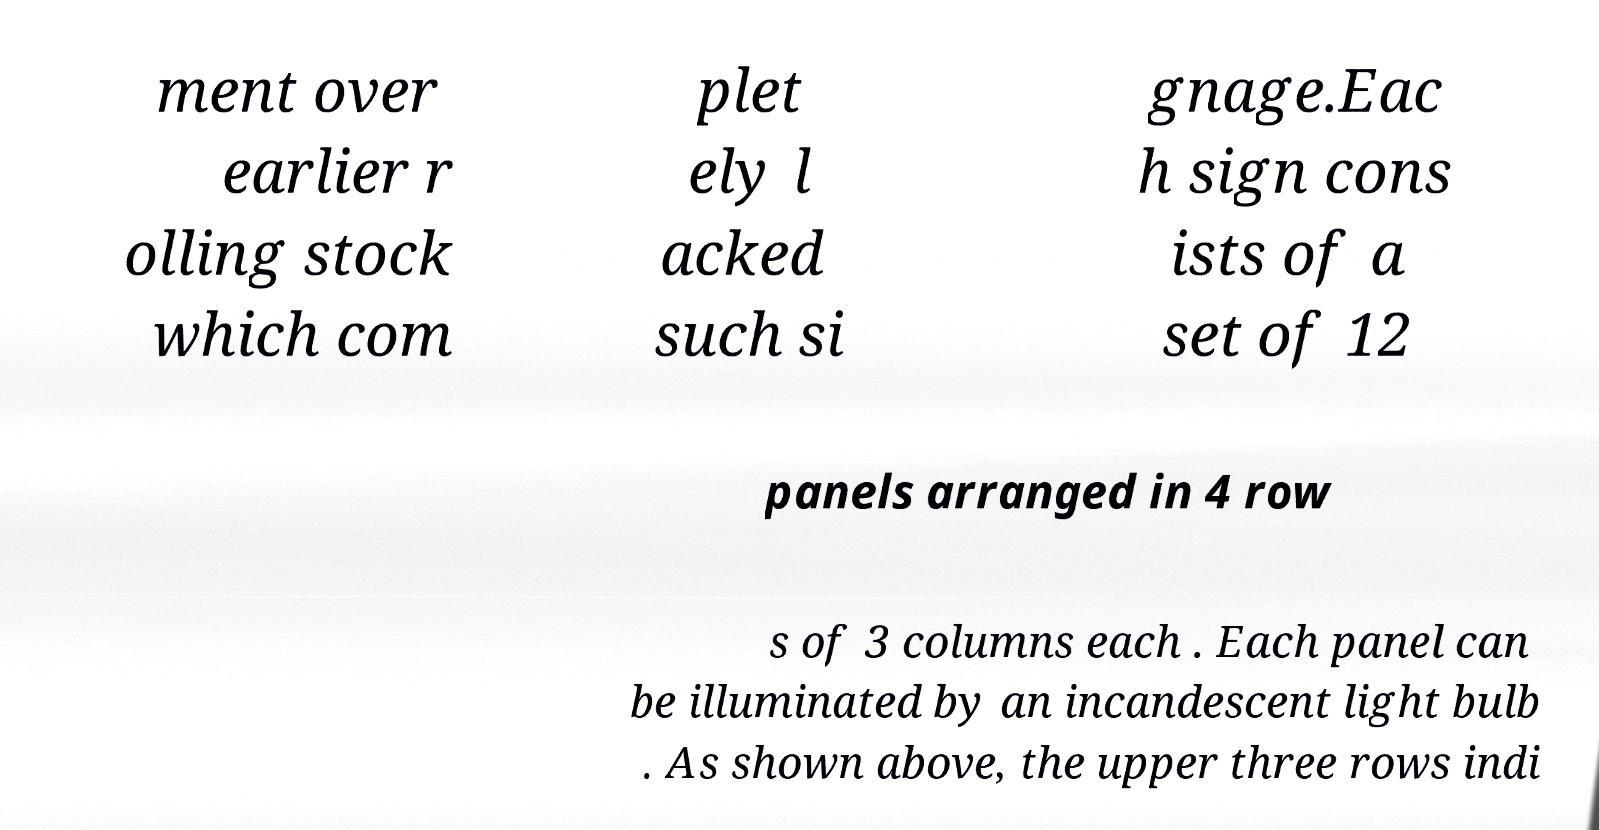I need the written content from this picture converted into text. Can you do that? ment over earlier r olling stock which com plet ely l acked such si gnage.Eac h sign cons ists of a set of 12 panels arranged in 4 row s of 3 columns each . Each panel can be illuminated by an incandescent light bulb . As shown above, the upper three rows indi 